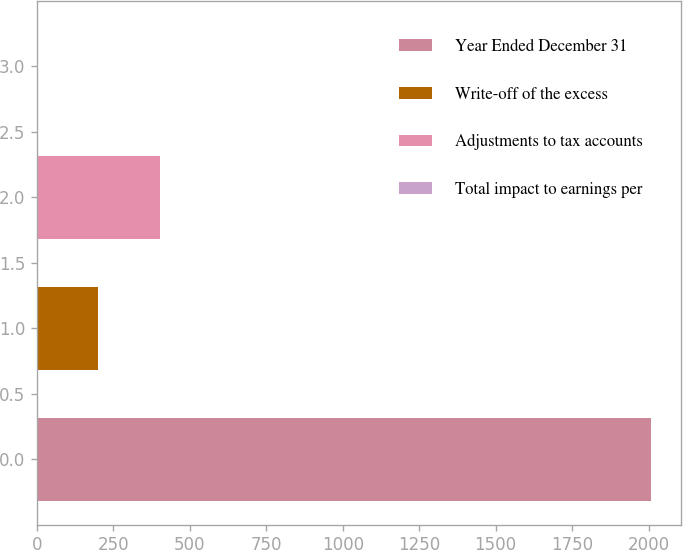Convert chart to OTSL. <chart><loc_0><loc_0><loc_500><loc_500><bar_chart><fcel>Year Ended December 31<fcel>Write-off of the excess<fcel>Adjustments to tax accounts<fcel>Total impact to earnings per<nl><fcel>2007<fcel>200.71<fcel>401.41<fcel>0.01<nl></chart> 